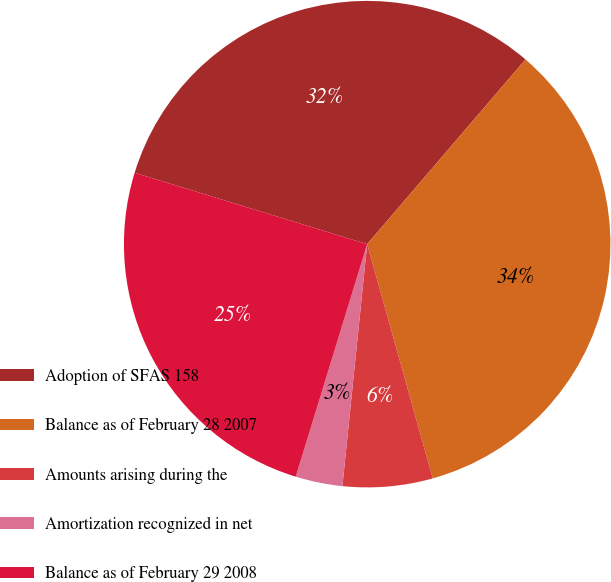<chart> <loc_0><loc_0><loc_500><loc_500><pie_chart><fcel>Adoption of SFAS 158<fcel>Balance as of February 28 2007<fcel>Amounts arising during the<fcel>Amortization recognized in net<fcel>Balance as of February 29 2008<nl><fcel>31.54%<fcel>34.38%<fcel>5.97%<fcel>3.12%<fcel>25.0%<nl></chart> 